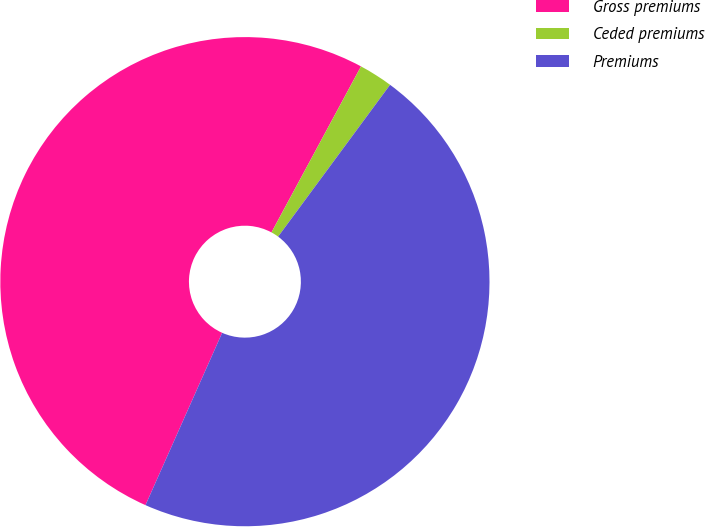Convert chart. <chart><loc_0><loc_0><loc_500><loc_500><pie_chart><fcel>Gross premiums<fcel>Ceded premiums<fcel>Premiums<nl><fcel>51.21%<fcel>2.24%<fcel>46.55%<nl></chart> 